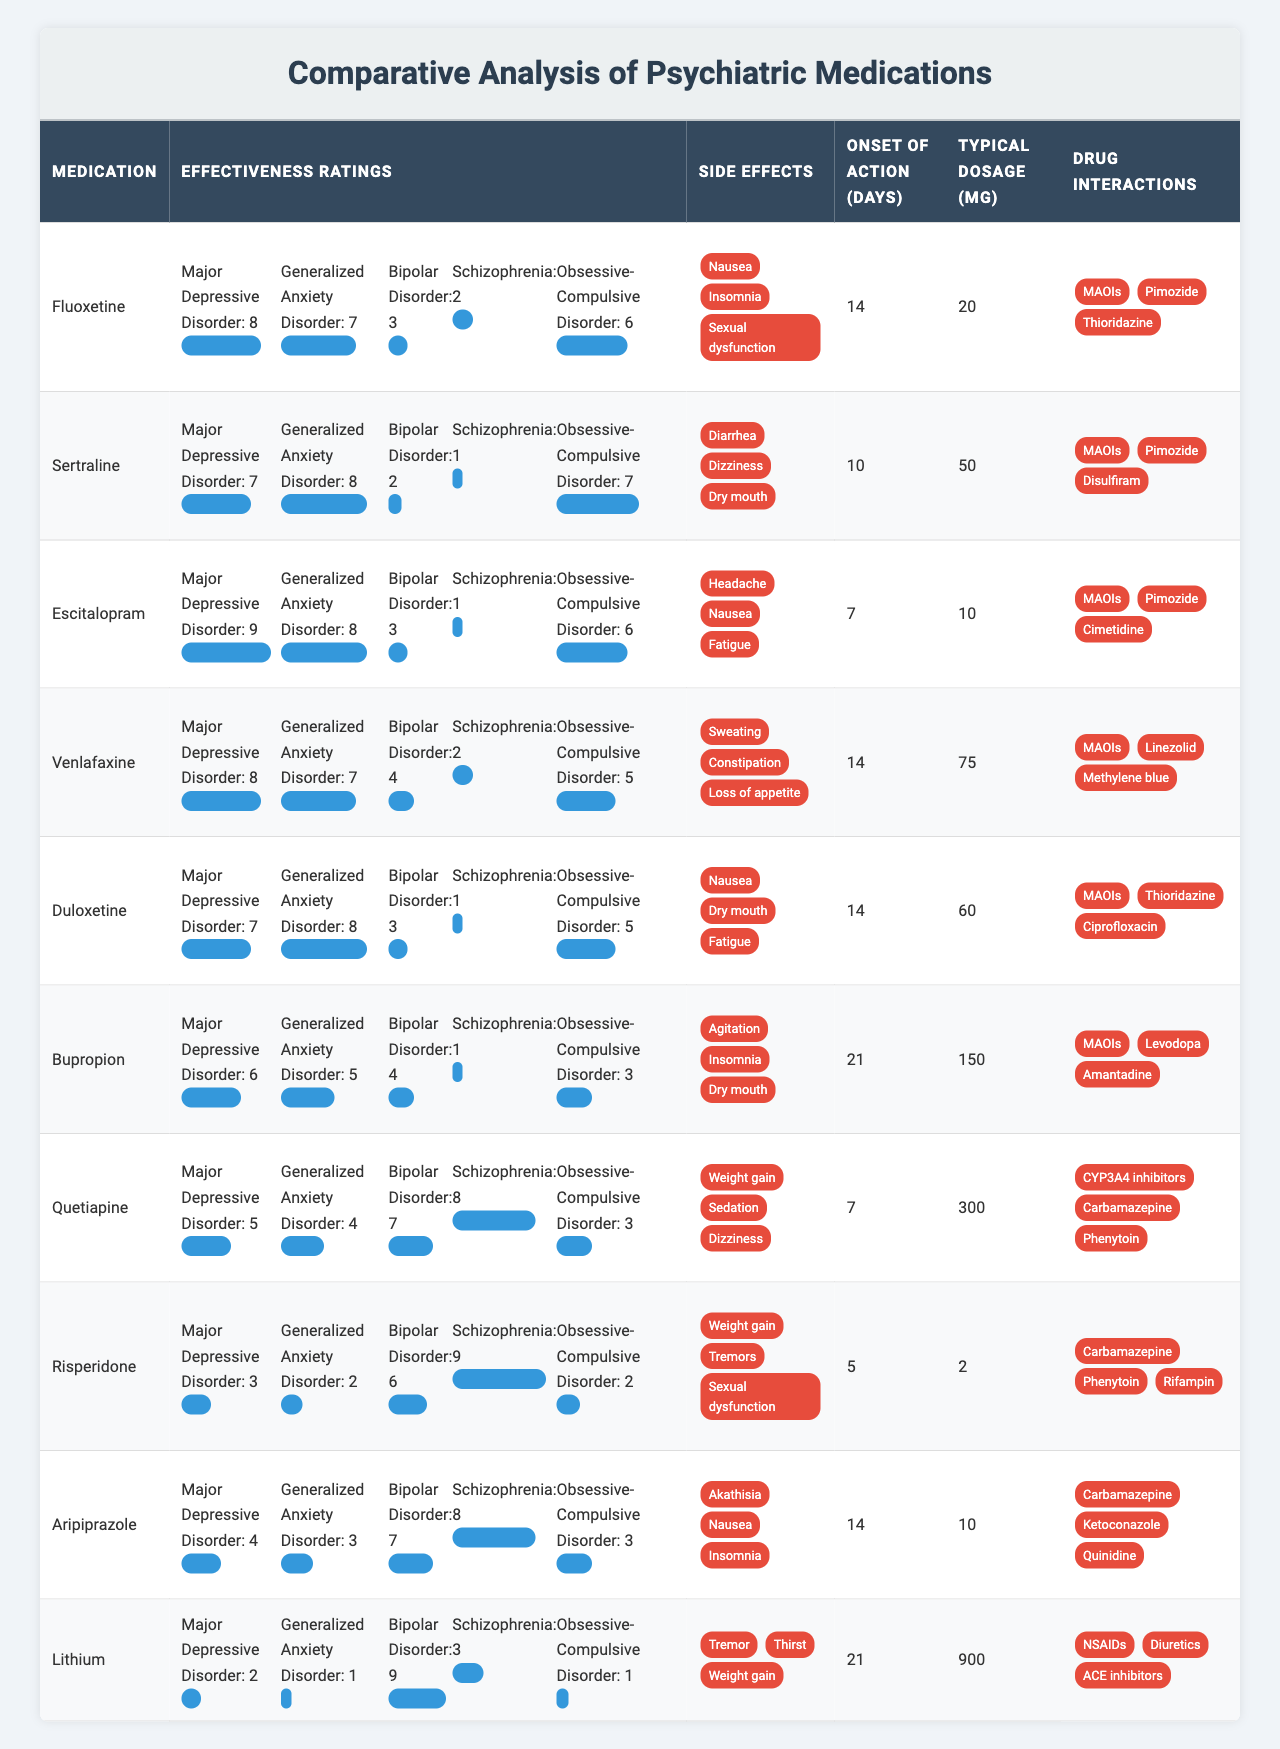What is the typical dosage of Sertraline? The table lists the typical dosage for each medication. For Sertraline, the dosage is specified as 50 mg.
Answer: 50 mg Which medication has the highest effectiveness rating for Major Depressive Disorder? The effectiveness ratings for Major Depressive Disorder show that Escitalopram has the highest rating at 9.
Answer: Escitalopram What are the side effects of Quetiapine? The side effects for Quetiapine are listed in the table as Weight gain, Sedation, and Dizziness.
Answer: Weight gain, Sedation, Dizziness How long does it take for Risperidone to show effects? According to the table, the onset of action for Risperidone is 5 days.
Answer: 5 days Which medication has the lowest rating for efficacy against Obsessive-Compulsive Disorder? The effectiveness ratings for Obsessive-Compulsive Disorder indicate that Risperidone has the lowest rating at 2.
Answer: Risperidone What is the average effectiveness rating for Duloxetine across all disorders? The ratings for Duloxetine are [7, 8, 3, 1, 5]. Summing these gives 7 + 8 + 3 + 1 + 5 = 24. There are 5 ratings, so the average is 24/5 = 4.8.
Answer: 4.8 Does Bupropion have any interactions with MAOIs? The table indicates that Bupropion has drug interactions with MAOIs, which confirms that it does have this interaction.
Answer: Yes What is the difference in effectiveness ratings between Fluoxetine for Major Depressive Disorder and for Schizophrenia? For Fluoxetine, the rating for Major Depressive Disorder is 8 and for Schizophrenia is 2. The difference is 8 - 2 = 6.
Answer: 6 Which medication has the highest likelihood of causing weight gain as a side effect? The medications with weight gain as a side effect are Quetiapine and Risperidone. Quetiapine is listed first.
Answer: Quetiapine If a patient is taking Aripiprazole, how many days should they expect before they see effects? The table indicates that the onset of action for Aripiprazole is 14 days.
Answer: 14 days What are the common side effects of both Duloxetine and Sertraline? The side effects of Duloxetine are Nausea, Dry mouth, and Fatigue while Sertraline's side effects are Diarrhea, Dizziness, and Dry mouth. The common side effect is Dry mouth.
Answer: Dry mouth What medication is effective for both Bipolar Disorder and Schizophrenia, and what are their effectiveness ratings? The table shows that Quetiapine is effective for both disorders, with ratings of 7 for Bipolar Disorder and 8 for Schizophrenia.
Answer: Quetiapine; 7 and 8 